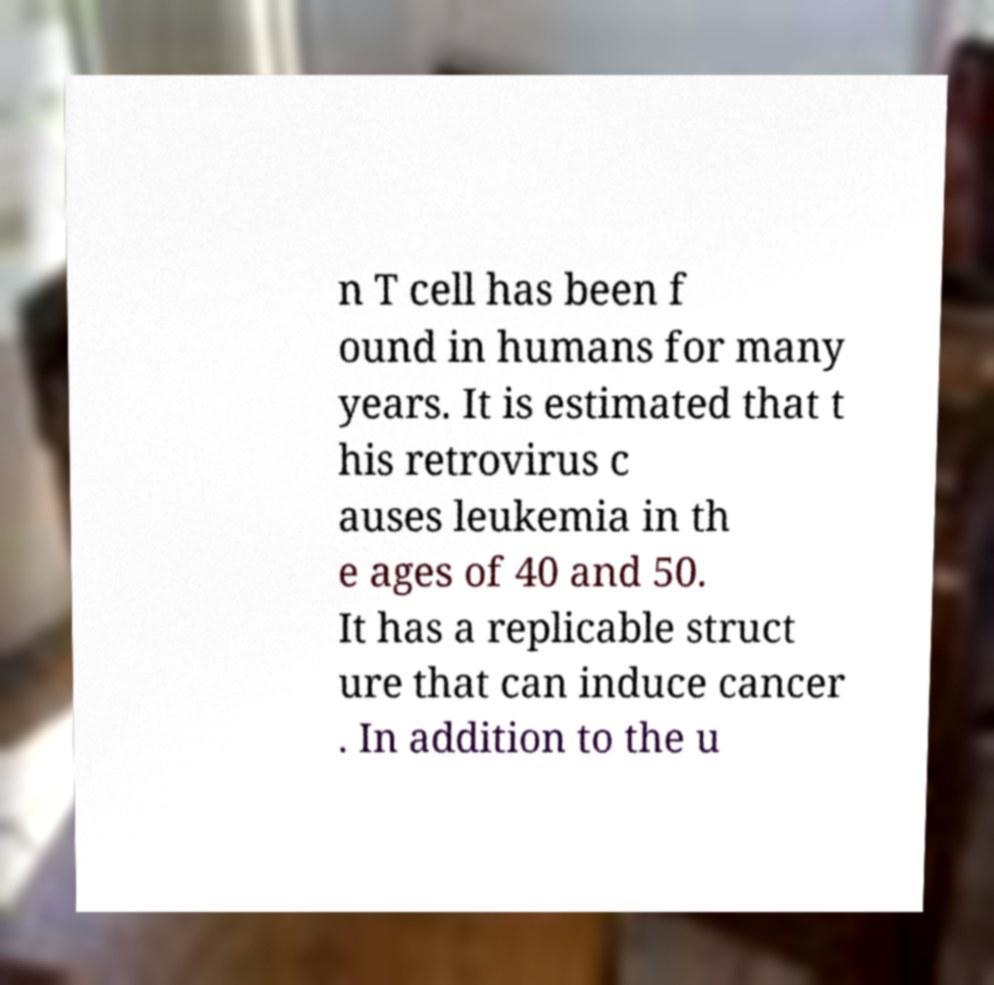I need the written content from this picture converted into text. Can you do that? n T cell has been f ound in humans for many years. It is estimated that t his retrovirus c auses leukemia in th e ages of 40 and 50. It has a replicable struct ure that can induce cancer . In addition to the u 